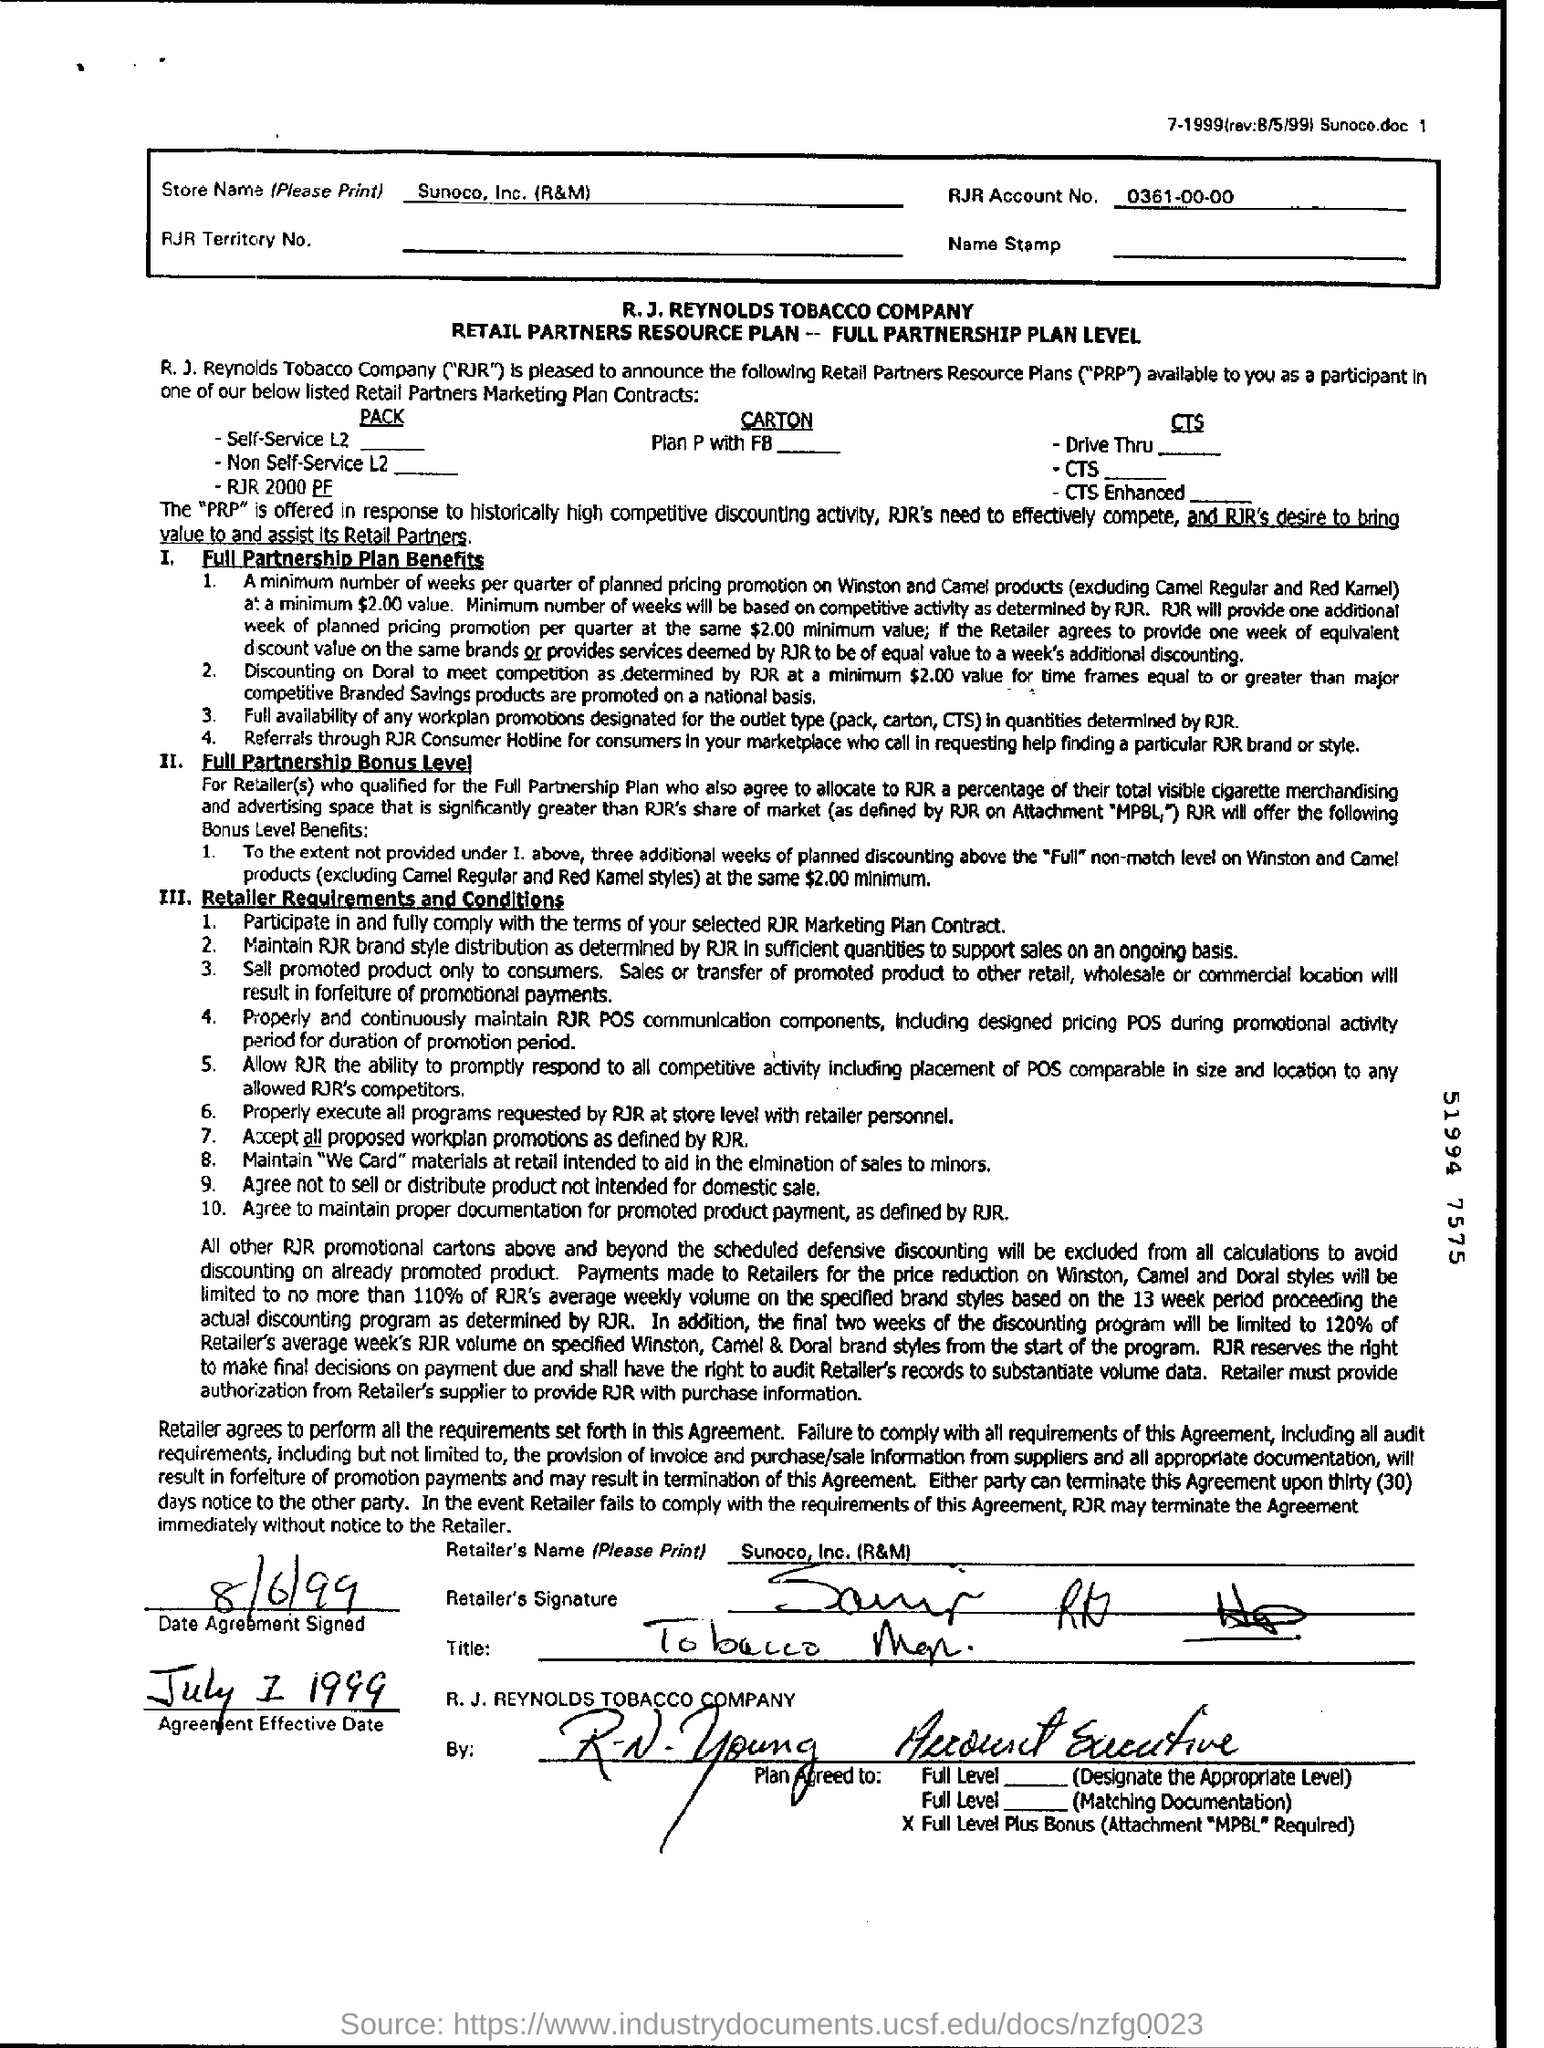What is the Retailer's Name given in the document?
Keep it short and to the point. Sunoco, Inc. (R&M). What is the RJR Account No?
Provide a succinct answer. 0361-00-00. What is the date of agreement signed?
Provide a succinct answer. 8/6/99. When is the Agreement Effective Date?
Make the answer very short. July 1 1999. 